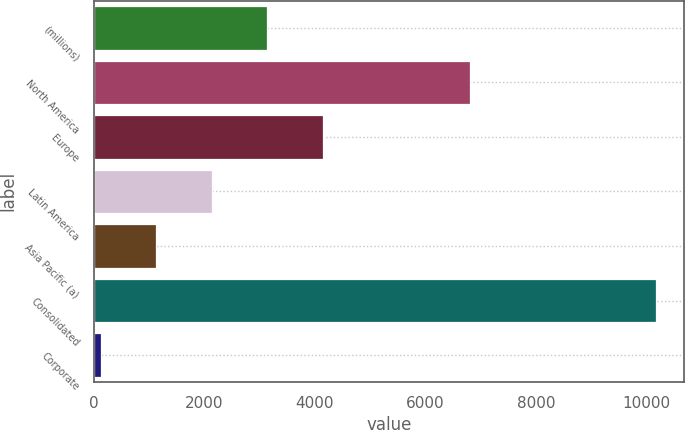Convert chart. <chart><loc_0><loc_0><loc_500><loc_500><bar_chart><fcel>(millions)<fcel>North America<fcel>Europe<fcel>Latin America<fcel>Asia Pacific (a)<fcel>Consolidated<fcel>Corporate<nl><fcel>3137.65<fcel>6807.8<fcel>4143.3<fcel>2132<fcel>1126.35<fcel>10177.2<fcel>120.7<nl></chart> 